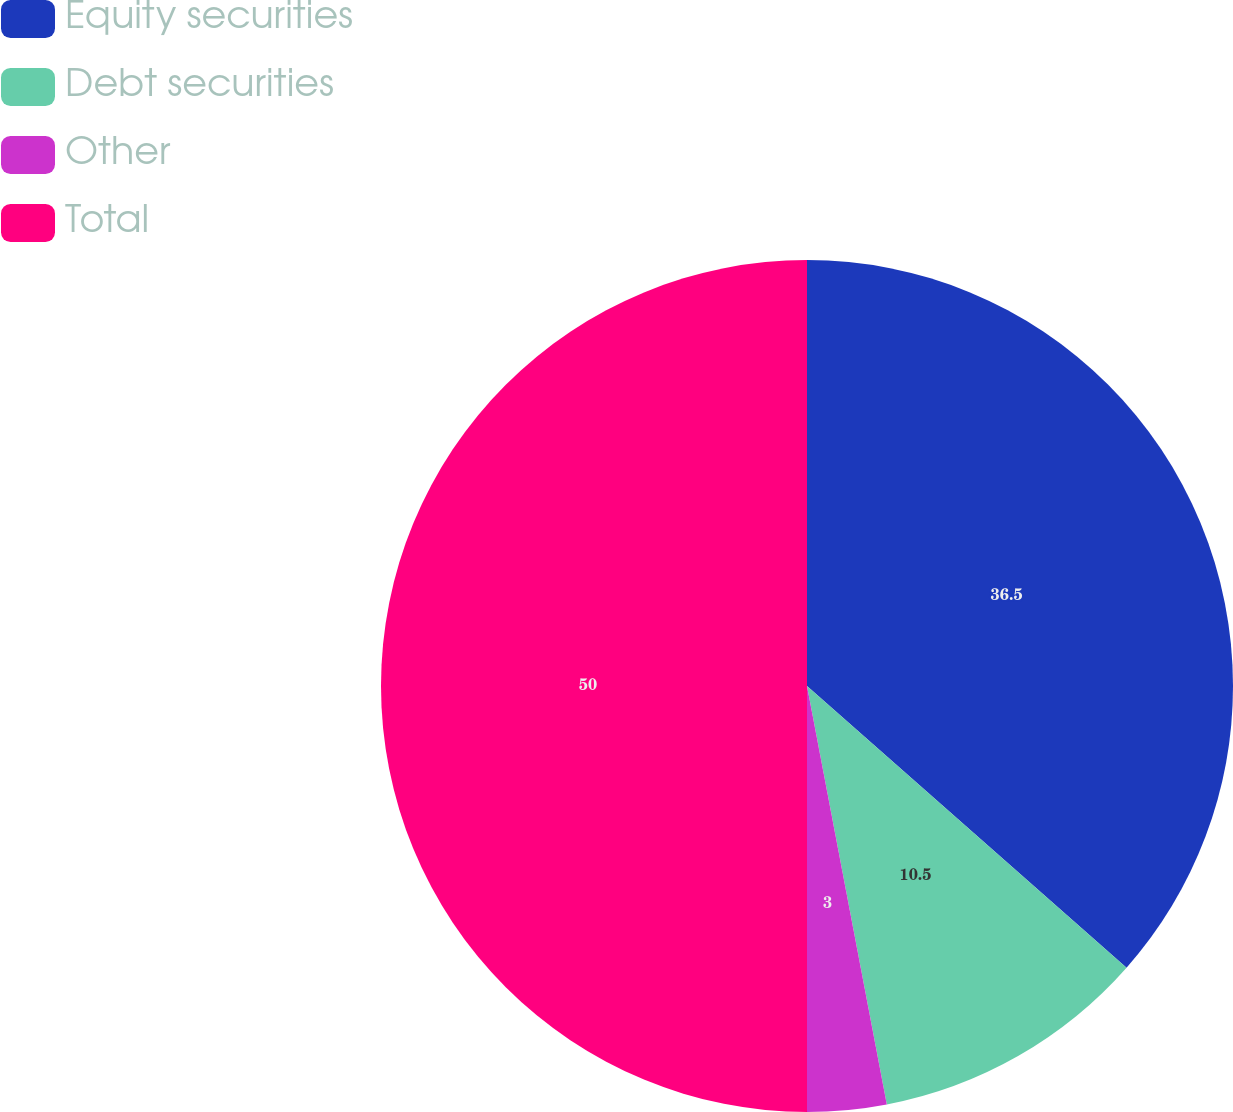<chart> <loc_0><loc_0><loc_500><loc_500><pie_chart><fcel>Equity securities<fcel>Debt securities<fcel>Other<fcel>Total<nl><fcel>36.5%<fcel>10.5%<fcel>3.0%<fcel>50.0%<nl></chart> 